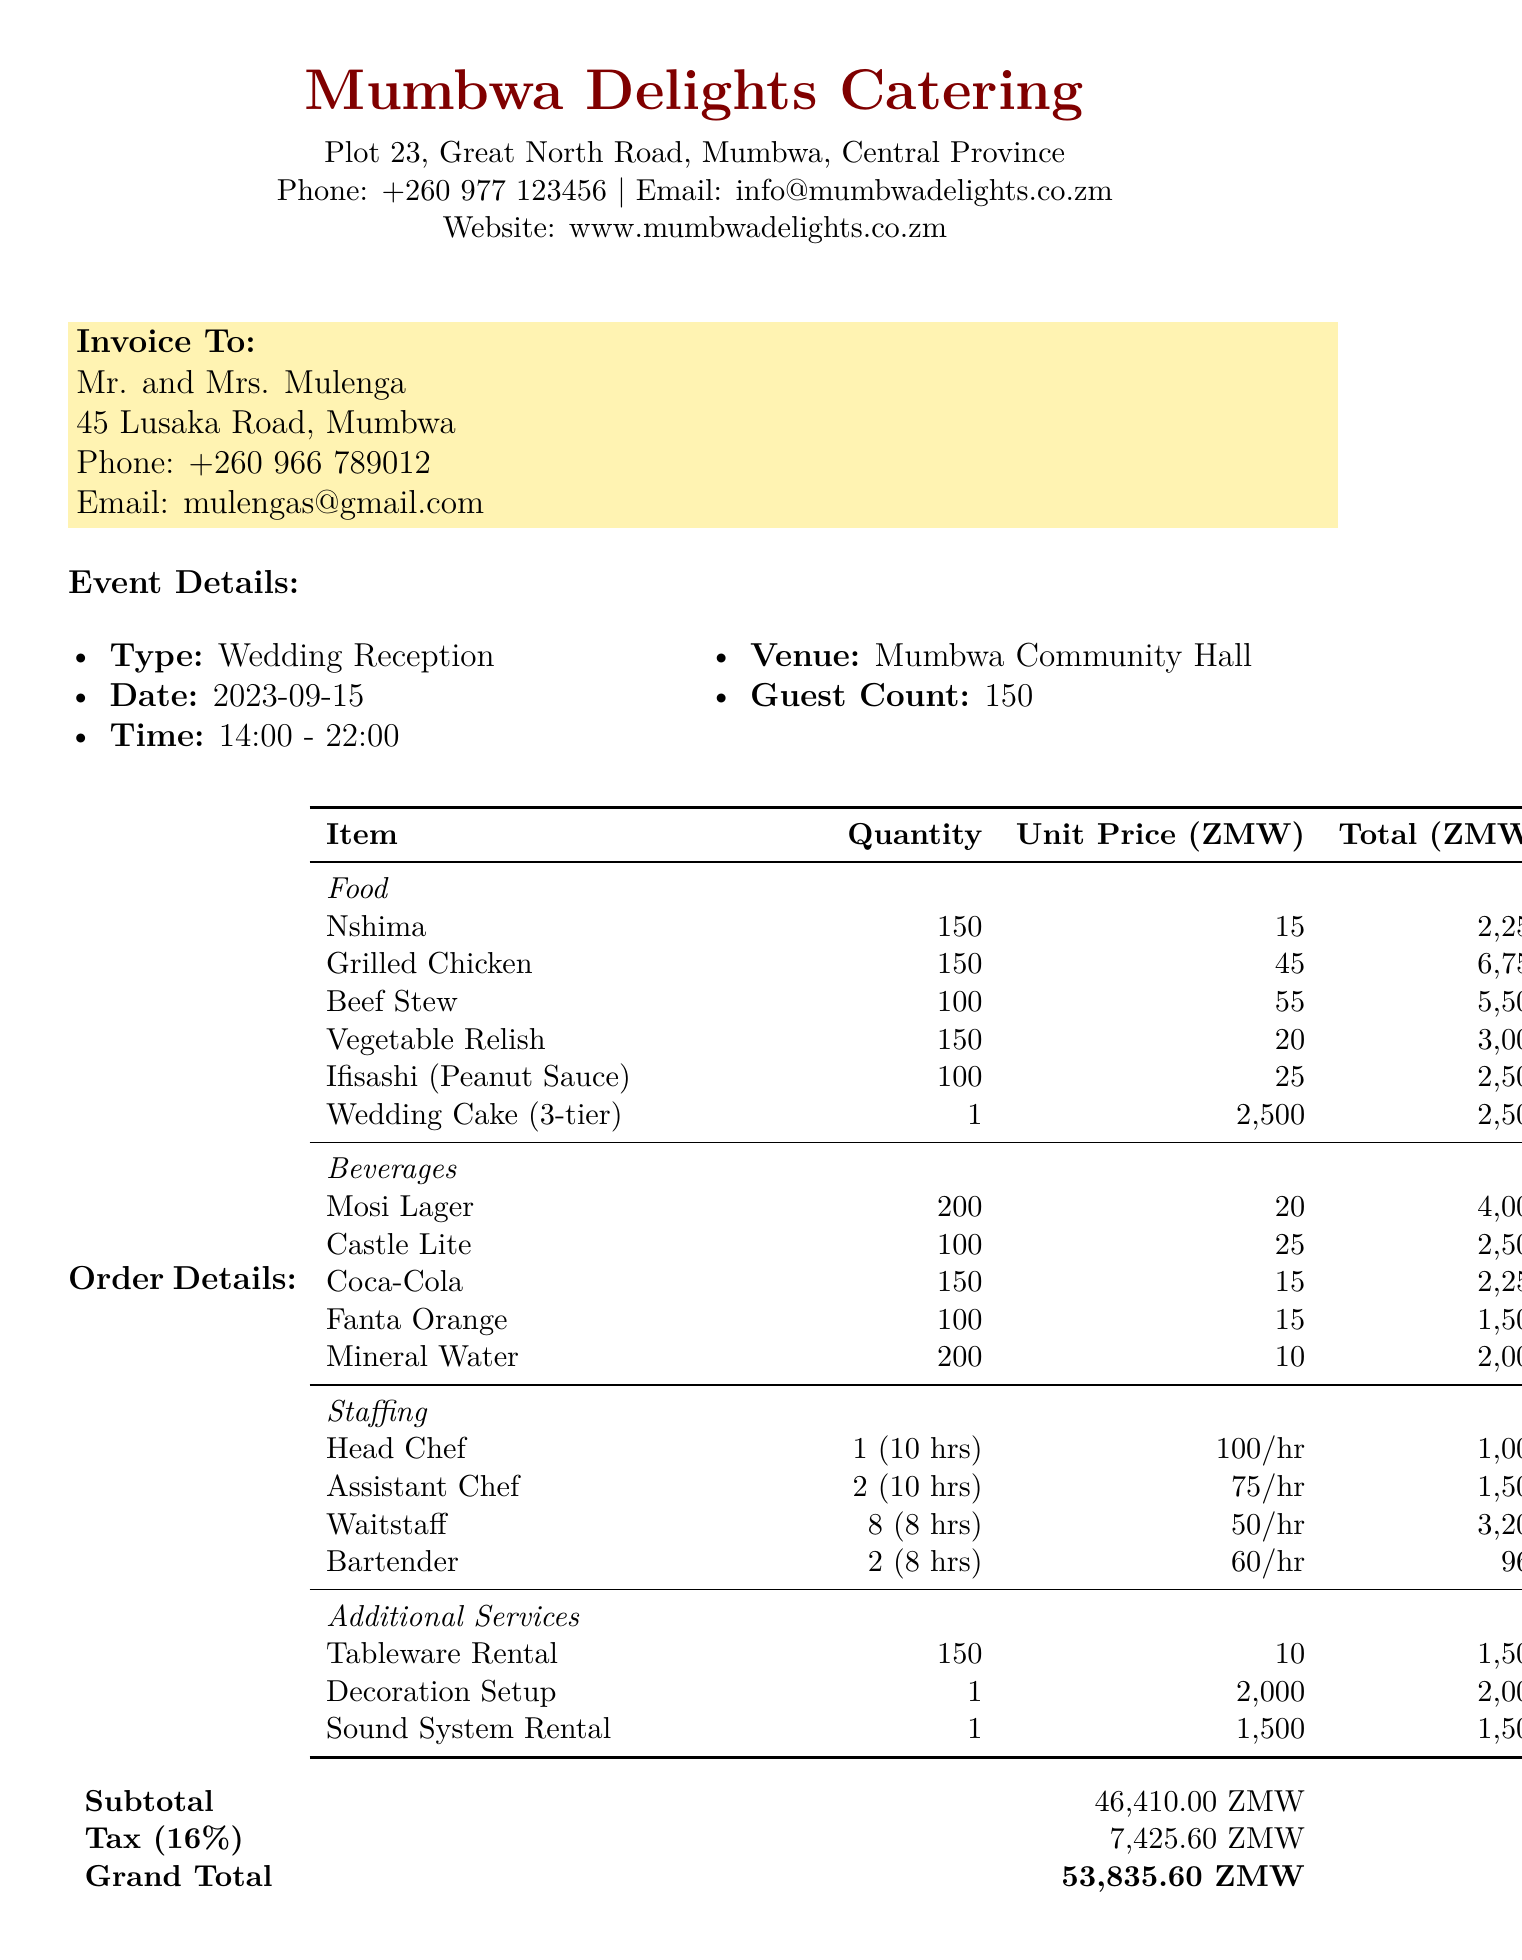what is the name of the catering company? The document states that the catering company is Mumbwa Delights Catering.
Answer: Mumbwa Delights Catering who is the client? The client information shows the names Mr. and Mrs. Mulenga.
Answer: Mr. and Mrs. Mulenga when is the wedding reception scheduled? The event details provide the date of the wedding reception as September 15, 2023.
Answer: 2023-09-15 how many guests are expected at the reception? The document mentions a guest count of 150.
Answer: 150 what is the total cost for beverages? The document lists the beverage total as 12,250 ZMW.
Answer: 12250 how many waitstaff are hired? According to the staffing section, there are 8 waitstaff hired for the event.
Answer: 8 what percentage of the grand total is tax? The document states that the tax amount is 16 percent of the subtotal.
Answer: 16% what is the deposit required for booking? According to the payment terms, a 50% deposit is due upon booking.
Answer: 50% what type of event is this invoice for? The event type mentioned in the document is a wedding reception.
Answer: Wedding Reception 